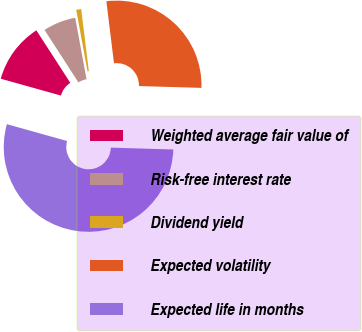<chart> <loc_0><loc_0><loc_500><loc_500><pie_chart><fcel>Weighted average fair value of<fcel>Risk-free interest rate<fcel>Dividend yield<fcel>Expected volatility<fcel>Expected life in months<nl><fcel>11.53%<fcel>6.24%<fcel>0.95%<fcel>27.41%<fcel>53.88%<nl></chart> 